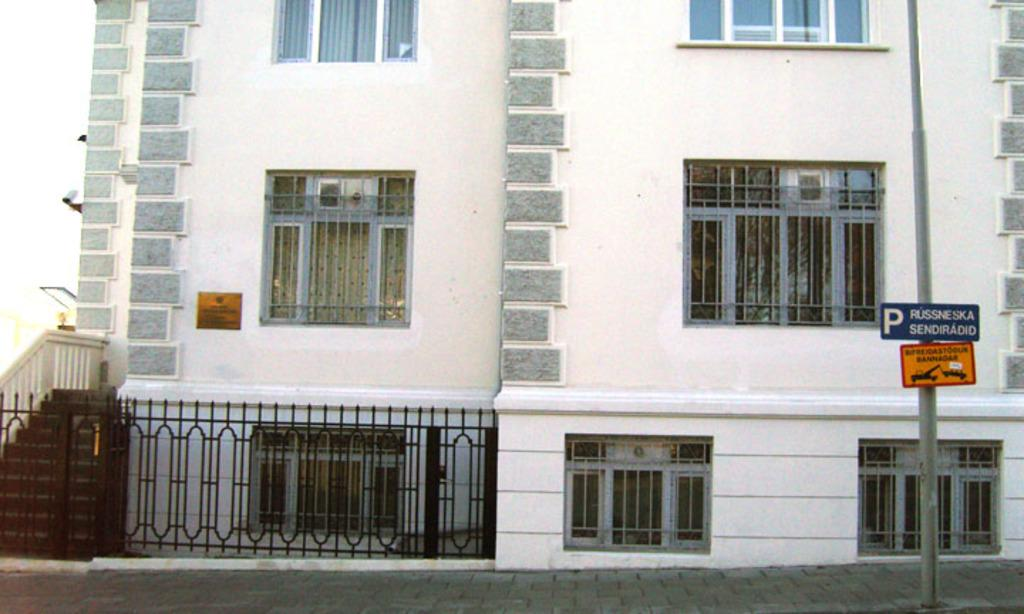What type of pathway is visible in the image? There is a walkway in the image. What structure can be seen in the image? There is a pole in the image. What feature is present along the walkway? There is a railing in the image. What can be seen in the background of the image? There is a building in the background of the image. What architectural feature is visible on the building? The building has windows. Can you see a gun in the image? No, there is no gun present in the image. Is there an ice sculpture visible in the image? No, there is no ice sculpture present in the image. 